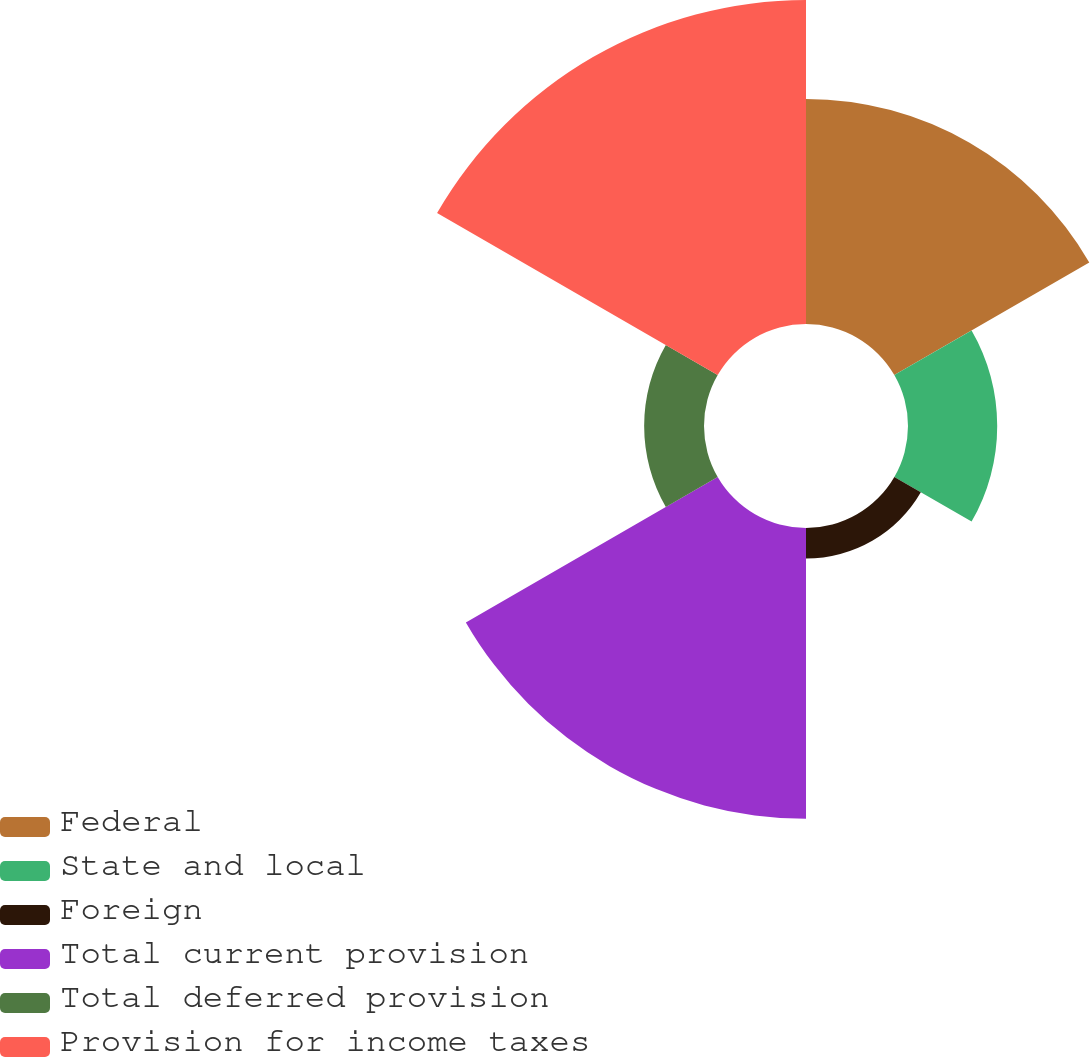Convert chart to OTSL. <chart><loc_0><loc_0><loc_500><loc_500><pie_chart><fcel>Federal<fcel>State and local<fcel>Foreign<fcel>Total current provision<fcel>Total deferred provision<fcel>Provision for income taxes<nl><fcel>22.08%<fcel>8.75%<fcel>3.0%<fcel>28.52%<fcel>5.87%<fcel>31.78%<nl></chart> 